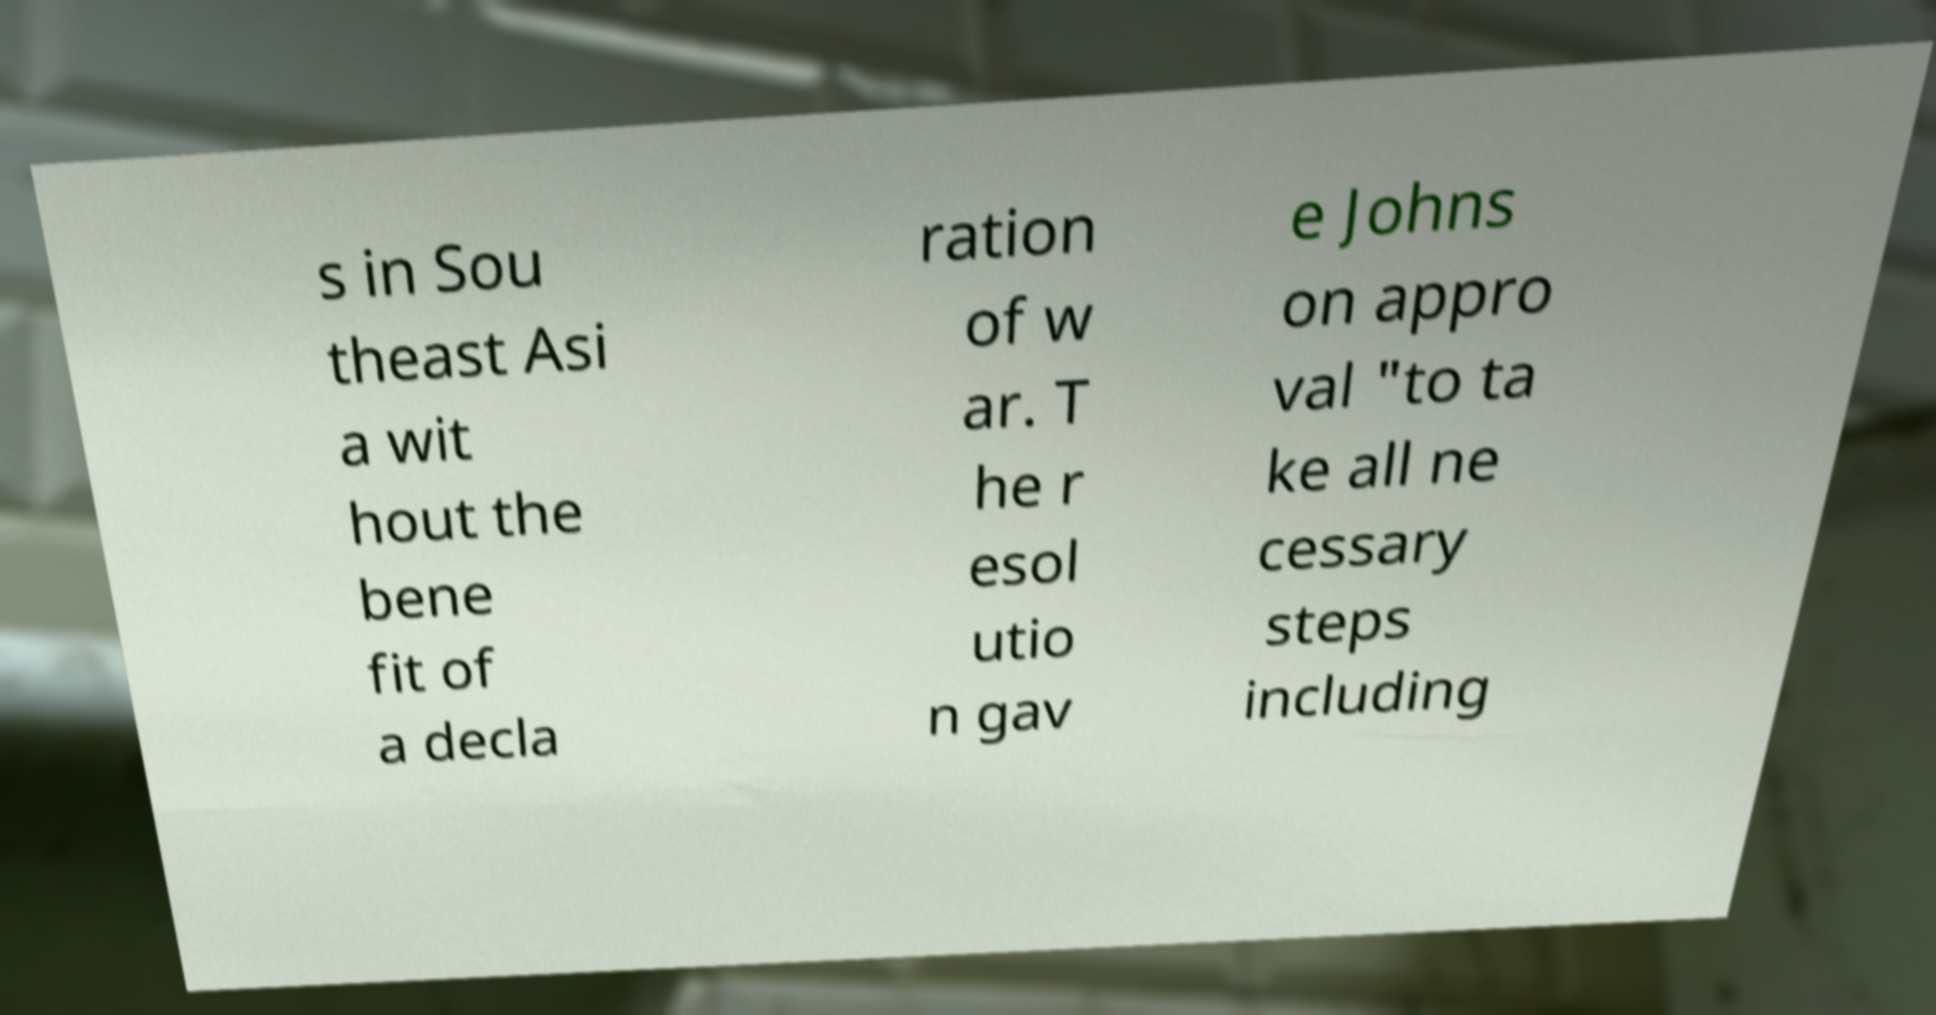Could you extract and type out the text from this image? s in Sou theast Asi a wit hout the bene fit of a decla ration of w ar. T he r esol utio n gav e Johns on appro val "to ta ke all ne cessary steps including 